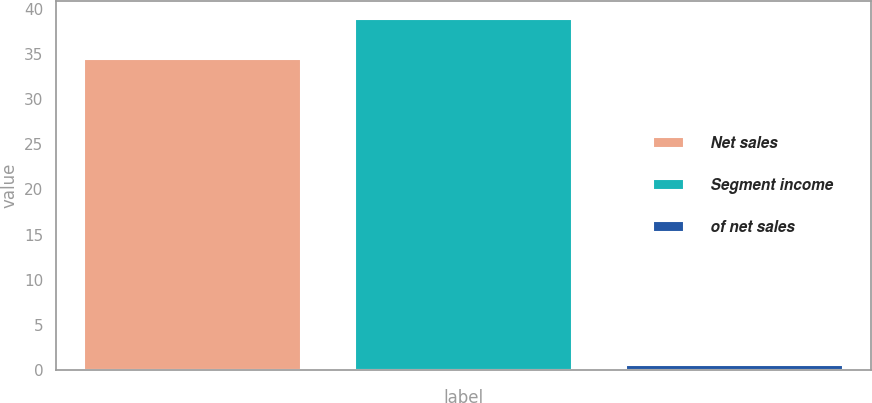Convert chart to OTSL. <chart><loc_0><loc_0><loc_500><loc_500><bar_chart><fcel>Net sales<fcel>Segment income<fcel>of net sales<nl><fcel>34.5<fcel>38.9<fcel>0.6<nl></chart> 